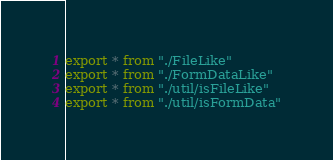<code> <loc_0><loc_0><loc_500><loc_500><_TypeScript_>export * from "./FileLike"
export * from "./FormDataLike"
export * from "./util/isFileLike"
export * from "./util/isFormData"
</code> 